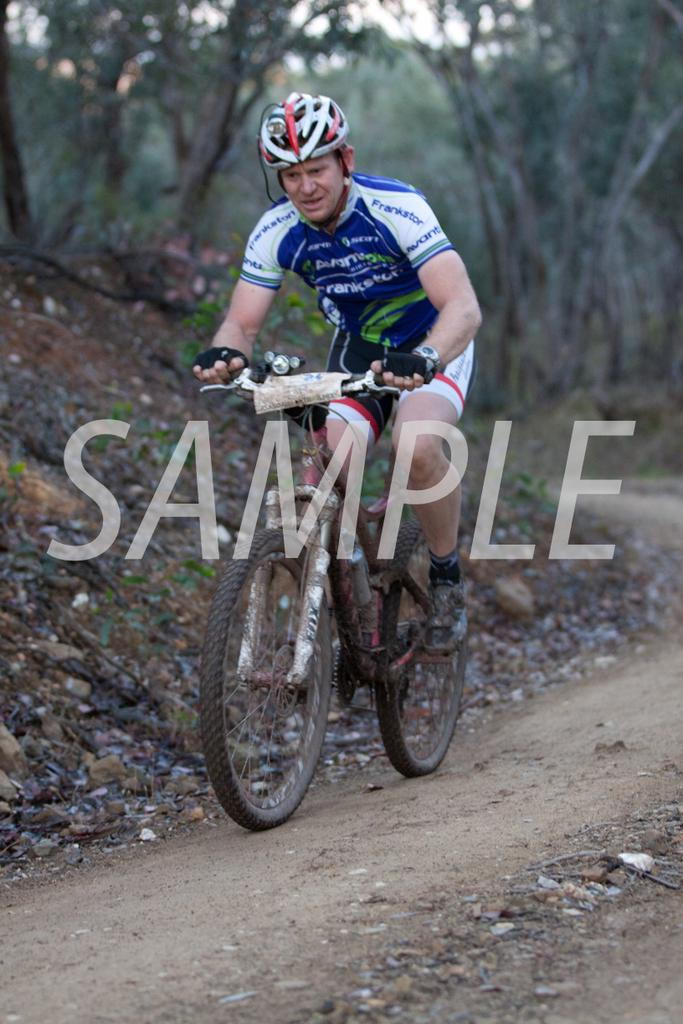What is the man in the image doing? The man is riding a bicycle in the image. What is the man wearing while riding the bicycle? The man is wearing a T-shirt and a helmet. What type of surface can be seen in the image? There is a surface with grass in the image. What can be seen in the background of the image? There are trees in the background of the image. How does the man's haircut compare to the trees in the background? There is no information about the man's haircut in the image, so it cannot be compared to the trees in the background. 